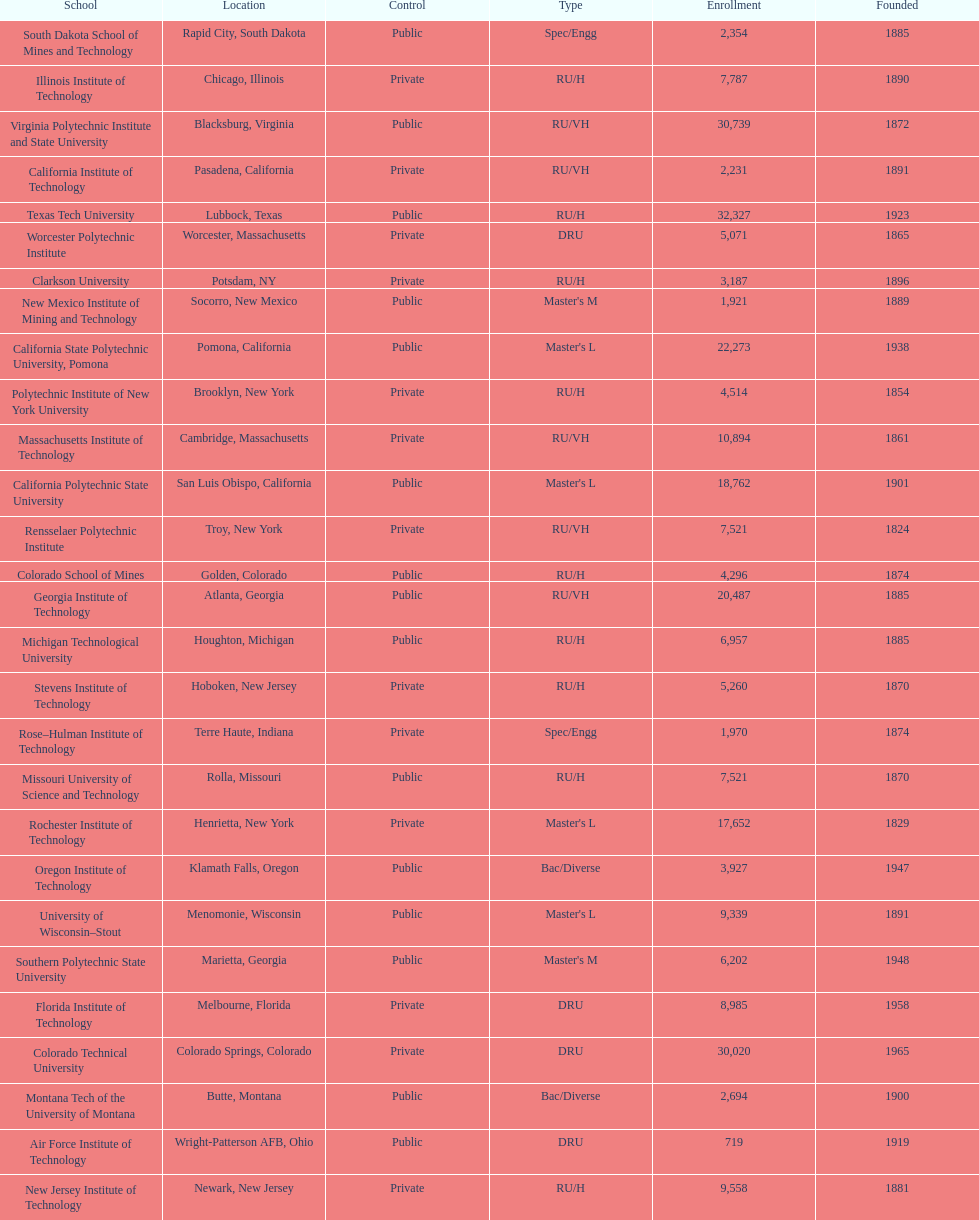Which school had the largest enrollment? Texas Tech University. 